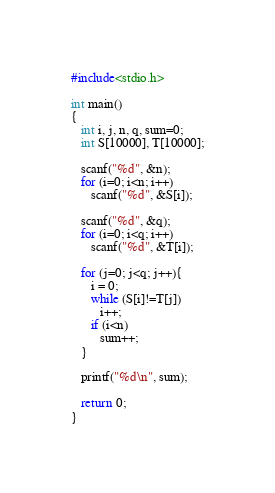<code> <loc_0><loc_0><loc_500><loc_500><_C_>#include<stdio.h>

int main()
{
   int i, j, n, q, sum=0;
   int S[10000], T[10000];

   scanf("%d", &n);
   for (i=0; i<n; i++)
      scanf("%d", &S[i]);

   scanf("%d", &q);
   for (i=0; i<q; i++)
      scanf("%d", &T[i]);

   for (j=0; j<q; j++){
      i = 0;
      while (S[i]!=T[j])
         i++;
      if (i<n)
         sum++;
   }

   printf("%d\n", sum);

   return 0;
}</code> 